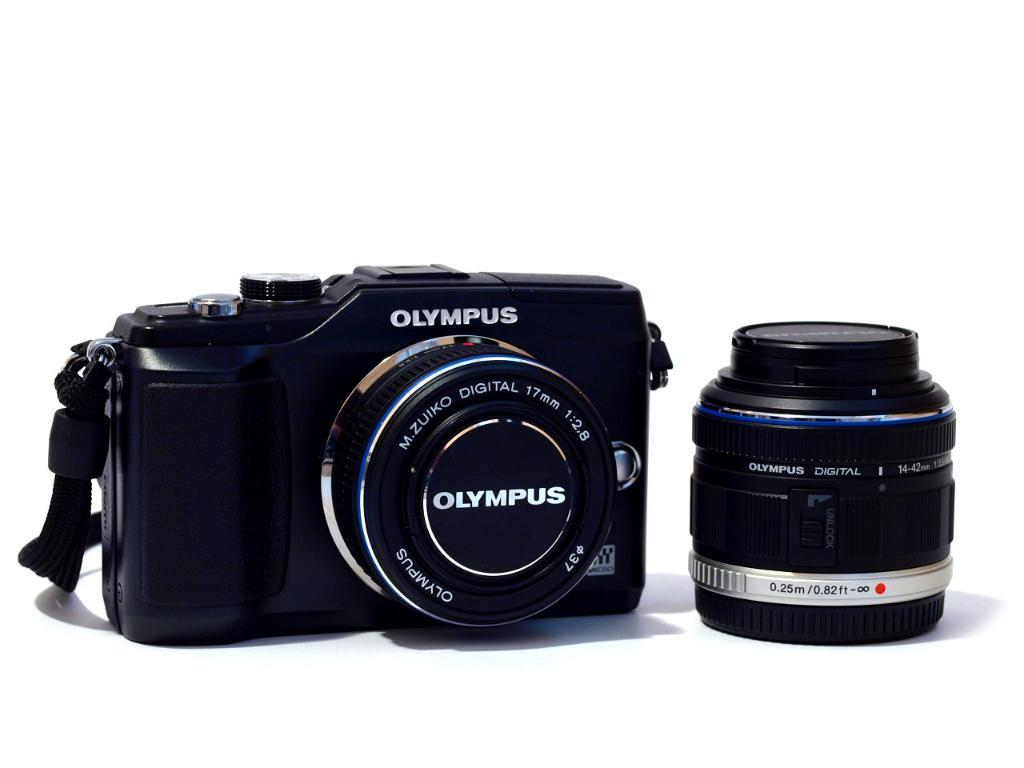<image>
Provide a brief description of the given image. The black camera has "OLYMPUS" written on it. 